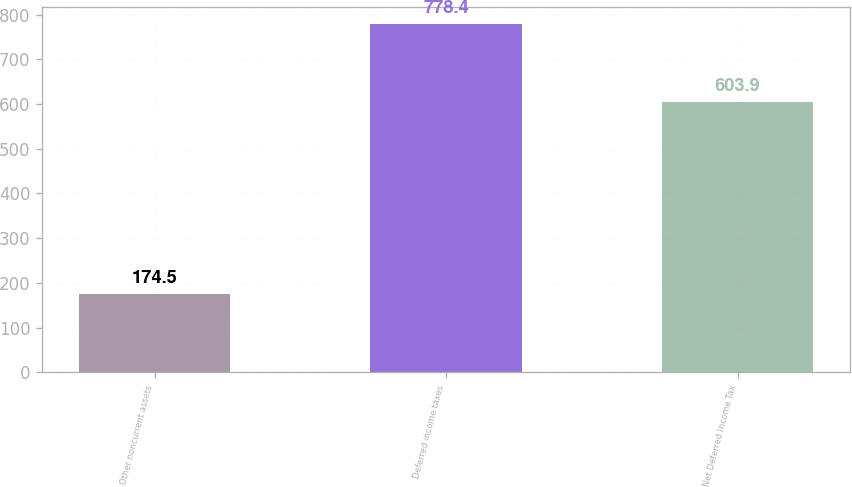Convert chart to OTSL. <chart><loc_0><loc_0><loc_500><loc_500><bar_chart><fcel>Other noncurrent assets<fcel>Deferred income taxes<fcel>Net Deferred Income Tax<nl><fcel>174.5<fcel>778.4<fcel>603.9<nl></chart> 